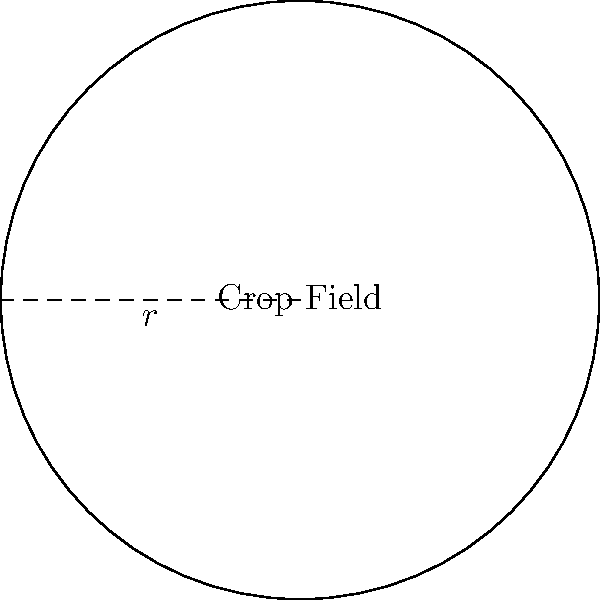A satellite image shows a perfectly circular crop field. If the radius of the field is 300 meters, what is the total area of the field in square meters? Round your answer to the nearest whole number. To calculate the area of a circular crop field, we need to use the formula for the area of a circle:

$$A = \pi r^2$$

Where:
$A$ = Area of the circle
$\pi$ = Pi (approximately 3.14159)
$r$ = Radius of the circle

Given:
Radius $(r) = 300$ meters

Step 1: Substitute the values into the formula
$$A = \pi (300)^2$$

Step 2: Calculate the square of the radius
$$A = \pi (90,000)$$

Step 3: Multiply by pi
$$A = 282,743.33...$$

Step 4: Round to the nearest whole number
$$A \approx 282,743 \text{ square meters}$$
Answer: 282,743 square meters 